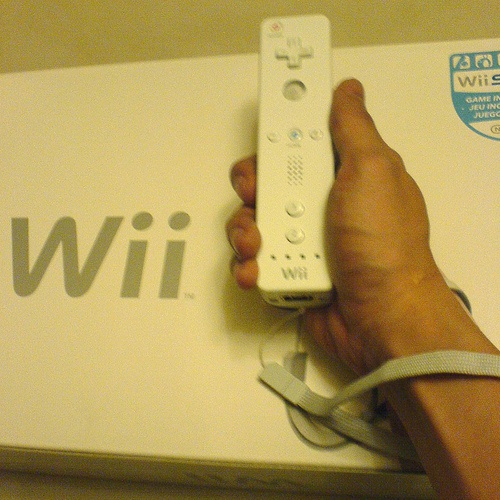Describe the objects in this image and their specific colors. I can see people in olive, maroon, and orange tones and remote in olive, khaki, and tan tones in this image. 